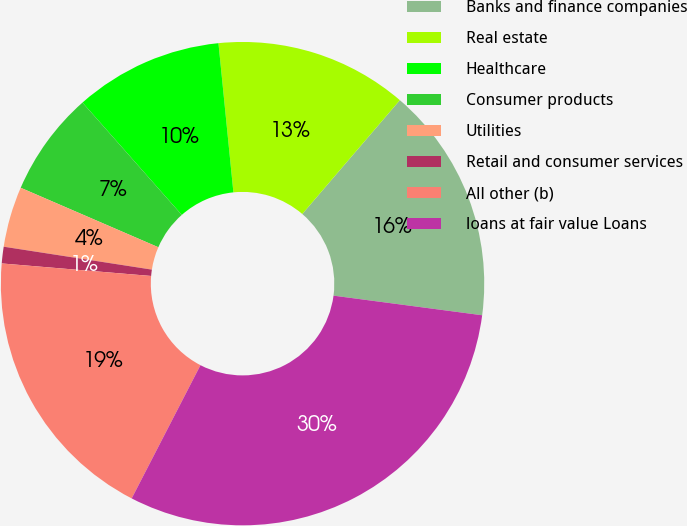Convert chart. <chart><loc_0><loc_0><loc_500><loc_500><pie_chart><fcel>Banks and finance companies<fcel>Real estate<fcel>Healthcare<fcel>Consumer products<fcel>Utilities<fcel>Retail and consumer services<fcel>All other (b)<fcel>loans at fair value Loans<nl><fcel>15.81%<fcel>12.87%<fcel>9.93%<fcel>6.99%<fcel>4.05%<fcel>1.11%<fcel>18.75%<fcel>30.5%<nl></chart> 